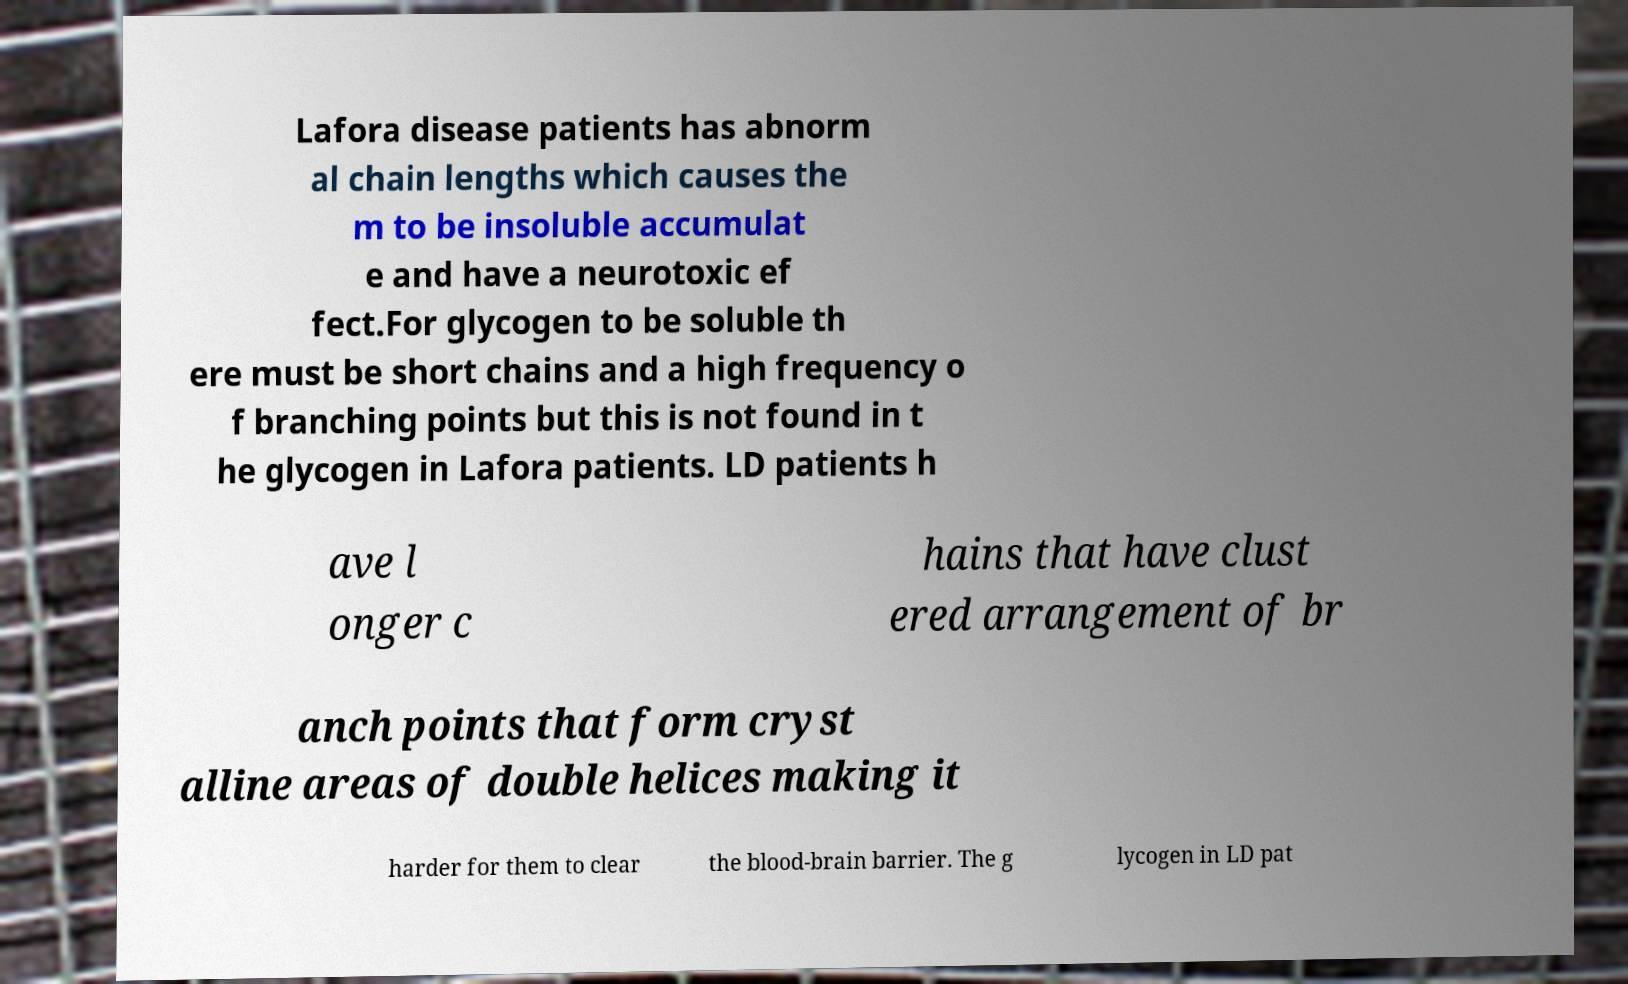Could you assist in decoding the text presented in this image and type it out clearly? Lafora disease patients has abnorm al chain lengths which causes the m to be insoluble accumulat e and have a neurotoxic ef fect.For glycogen to be soluble th ere must be short chains and a high frequency o f branching points but this is not found in t he glycogen in Lafora patients. LD patients h ave l onger c hains that have clust ered arrangement of br anch points that form cryst alline areas of double helices making it harder for them to clear the blood-brain barrier. The g lycogen in LD pat 